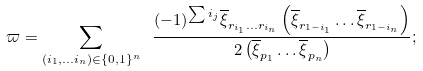<formula> <loc_0><loc_0><loc_500><loc_500>\varpi = \sum _ { ( i _ { 1 } , \dots i _ { n } ) \in \{ 0 , 1 \} ^ { n } } \ \frac { ( - 1 ) ^ { \sum i _ { j } } { \overline { \xi } } _ { r _ { i _ { 1 } } \dots r _ { i _ { n } } } \left ( { \overline { \xi } } _ { r _ { 1 - i _ { 1 } } } \dots { \overline { \xi } } _ { r _ { 1 - i _ { n } } } \right ) } { 2 \left ( { \overline { \xi } } _ { p _ { 1 } } \dots { \overline { \xi } } _ { p _ { n } } \right ) } ;</formula> 